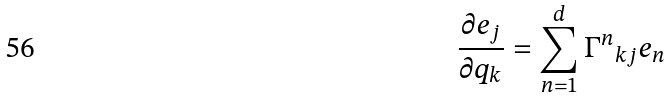<formula> <loc_0><loc_0><loc_500><loc_500>\frac { \partial e _ { j } } { \partial q _ { k } } = \sum _ { n = 1 } ^ { d } { \Gamma ^ { n } } _ { k j } e _ { n }</formula> 